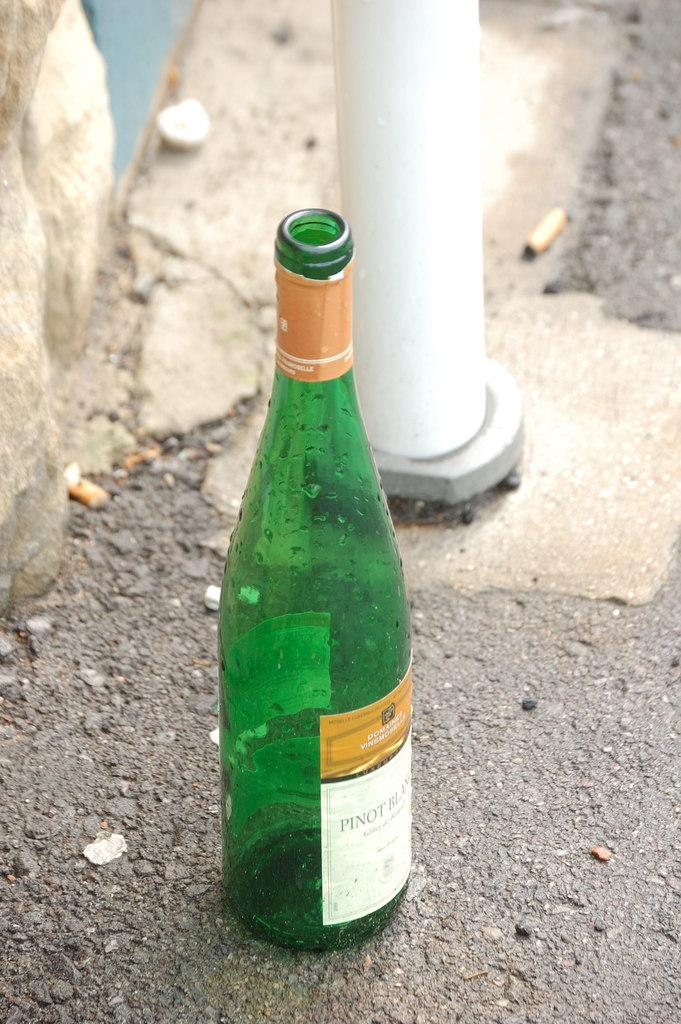What color is the bottle in the image? The bottle in the image is green. Where is the bottle located in the image? The bottle is on the ground. What type of harmony is being played in the background of the image? There is no background music or harmony present in the image; it only features a green color bottle on the ground. 